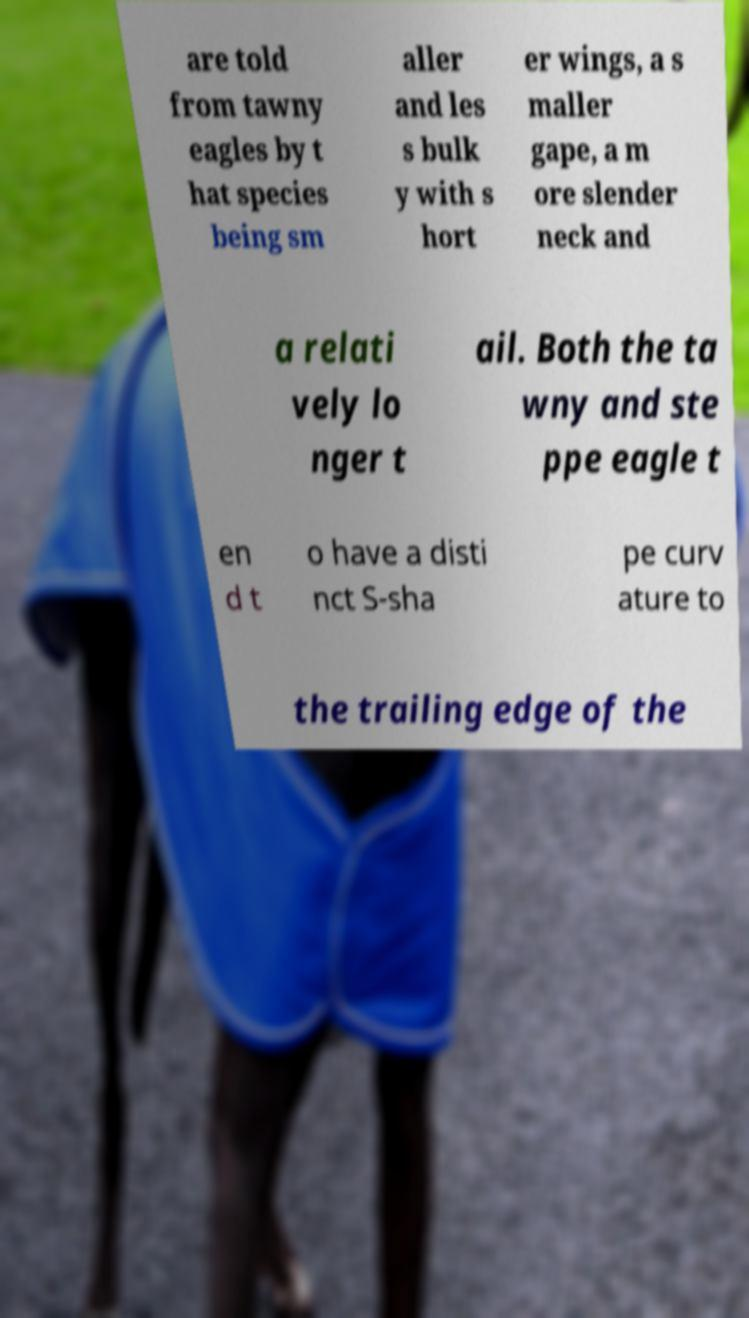There's text embedded in this image that I need extracted. Can you transcribe it verbatim? are told from tawny eagles by t hat species being sm aller and les s bulk y with s hort er wings, a s maller gape, a m ore slender neck and a relati vely lo nger t ail. Both the ta wny and ste ppe eagle t en d t o have a disti nct S-sha pe curv ature to the trailing edge of the 